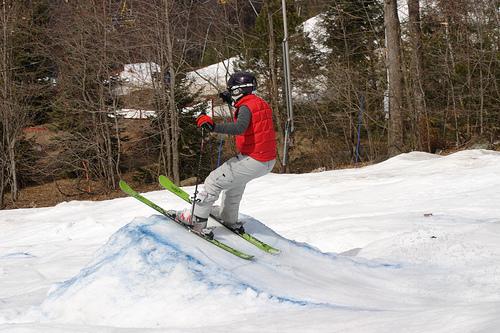Was the man standing still when this picture was taken?
Write a very short answer. No. What color is the man's gloves?
Be succinct. Red. What color is their helmet?
Concise answer only. Black. Is the man going to slide backward?
Answer briefly. Yes. 